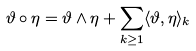Convert formula to latex. <formula><loc_0><loc_0><loc_500><loc_500>\vartheta \circ \eta = \vartheta \wedge \eta + \sum _ { k \geq 1 } \langle \vartheta , \eta \rangle _ { k }</formula> 